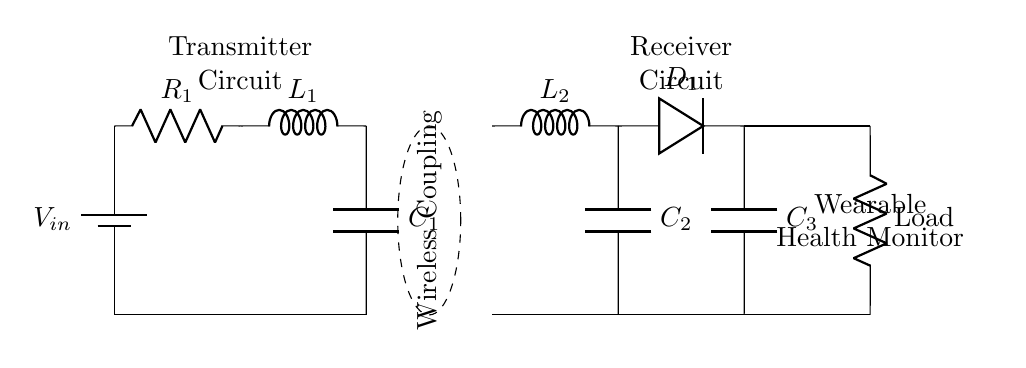What is the input voltage of the transmitter circuit? The input voltage is denoted as V_in in the circuit diagram, which is clearly labeled next to the battery component.
Answer: V_in How many capacitors are present in the circuit? There are three capacitors visible in the circuit diagram, labeled as C_1, C_2, and C_3. Counting these components gives the total number of capacitors.
Answer: 3 What component is the load in the receiver circuit? The load in the receiver circuit is represented by the component labeled as Load near the bottom right of the circuit, indicating where the current will flow towards an external device.
Answer: Load What type of circuit is represented? This circuit represents a wireless charging circuit, as indicated by the dashed ellipse labeled Wireless Coupling, which is crucial for transferring power without physical connections.
Answer: Wireless charging circuit Which component is responsible for rectification in the circuit? The component responsible for rectification is D_1, which is labeled as a diode in the receiver section of the circuit. Diodes are commonly used for converting AC to DC, making it crucial for charging the wearable device.
Answer: D_1 What is the purpose of L_1 and L_2 in the circuit? L_1 and L_2 are inductors, which are crucial for creating the necessary magnetic fields for wireless energy transfer between the transmitter and receiver circuits. Their presence is essential for the charging process in wireless systems.
Answer: Inductors for coupling What is the configuration of the capacitors in the receiver circuit? The capacitors C_2 and C_3 are in parallel in the receiver circuit, as they are connected along the same vertical path and both connect to the ground, which is indicative of parallel configuration.
Answer: Parallel 